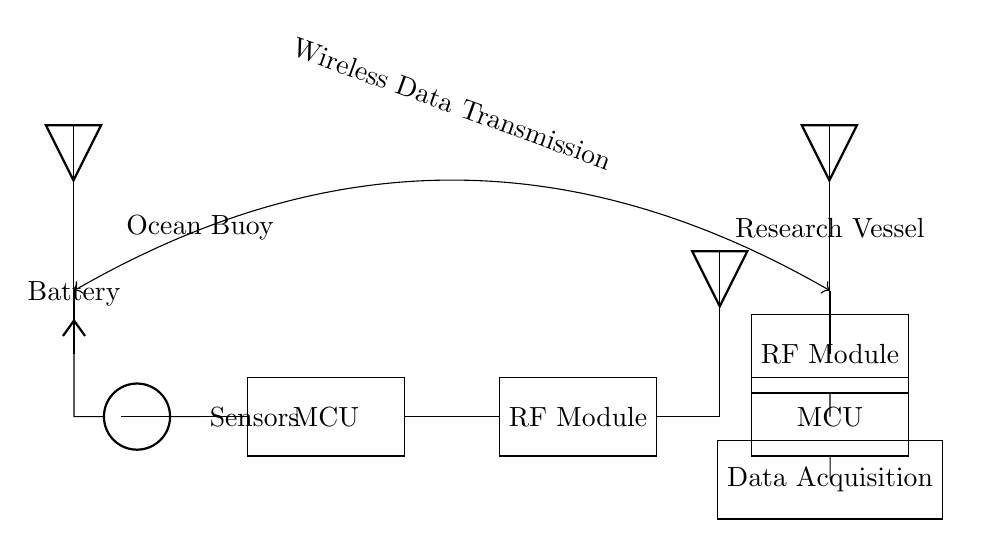What is the primary purpose of the RF module in the circuit? The RF module is used for wireless data transmission between the ocean buoy and research vessel. It interfaces with the microcontroller in the buoy and the data acquisition system in the vessel to send and receive signals.
Answer: Wireless communication What component powers the sensors in the ocean buoy? The battery, indicated as VCC in the circuit, provides the necessary electrical power to the sensors connected to it, ensuring they operate properly and can collect data.
Answer: Battery How many microcontrollers are present in the circuit? There are two microcontrollers: one in the ocean buoy and one in the research vessel. Both are essential for processing data—one gathers data from sensors, while the other assists in data acquisition onboard the vessel.
Answer: Two What type of connection is indicated between the ocean buoy and the research vessel? The connection is specified as a wireless data transmission, which allows for real-time communication without physical cabling, enhancing flexibility and usability in marine environments.
Answer: Wireless data transmission What device is located at the top of each side of the circuit? At the top of each side, there are antennas—one on the ocean buoy for sending data and one on the research vessel for receiving data, which is crucial for establishing the wireless communication link.
Answer: Antenna What role does the data acquisition system play in the research vessel? The data acquisition system collects, stores, and analyzes the data transmitted from the buoy's sensors via the microcontroller, facilitating research and monitoring activities related to marine environments.
Answer: Data collection and analysis 